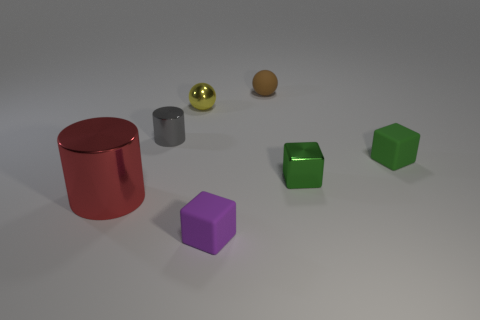Add 2 tiny cyan spheres. How many objects exist? 9 Subtract all cylinders. How many objects are left? 5 Subtract 0 gray cubes. How many objects are left? 7 Subtract all metallic objects. Subtract all cyan rubber objects. How many objects are left? 3 Add 6 tiny cubes. How many tiny cubes are left? 9 Add 7 small balls. How many small balls exist? 9 